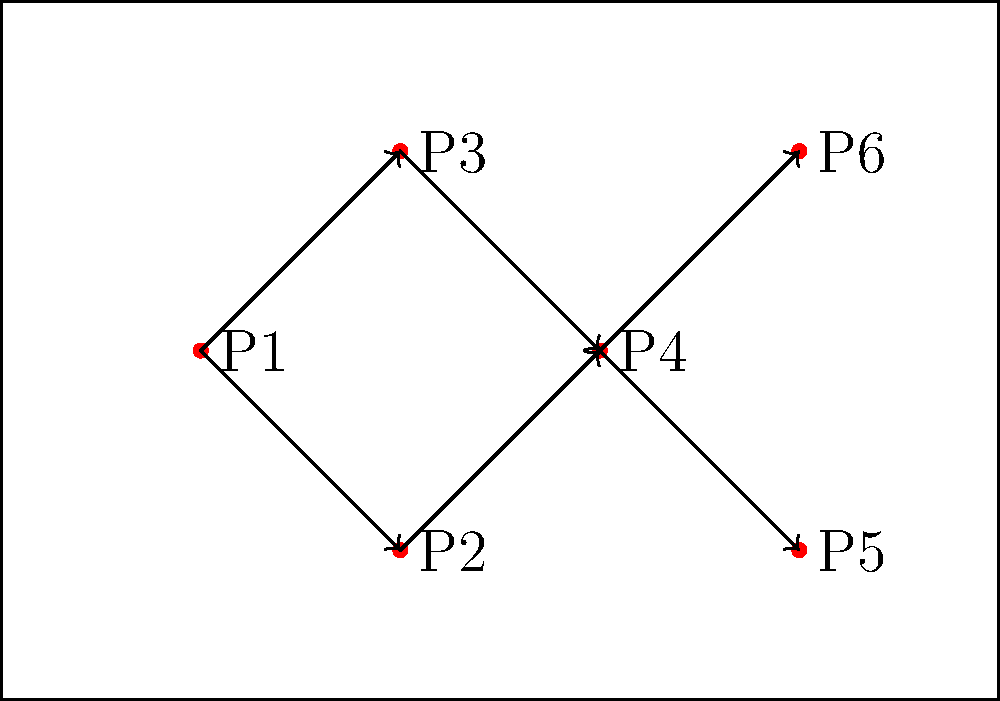As a keen observer of JCB Bhilai Brothers FC, you've noticed their unique passing strategy. In the diagram, six players (P1 to P6) are positioned on the pitch with arrows indicating the most effective passing routes. What is the minimum number of passes required for the ball to reach either P5 or P6 from P1? Let's analyze the passing routes step-by-step:

1. P1 is the starting point (likely a defender or deep-lying midfielder).
2. From P1, there are two initial passing options:
   a. P1 to P2
   b. P1 to P3
3. Both P2 and P3 can pass to P4, which acts as a central hub.
4. From P4, the ball can be passed to either P5 or P6.

To find the minimum number of passes:
1. P1 to P2 or P3 (1 pass)
2. P2 or P3 to P4 (1 pass)
3. P4 to P5 or P6 (1 pass)

Therefore, the minimum number of passes required is 3.

This passing strategy likely represents JCB Bhilai Brothers FC's quick transition from defense to attack, utilizing a central playmaker (P4) to distribute the ball to the forwards (P5 and P6).
Answer: 3 passes 